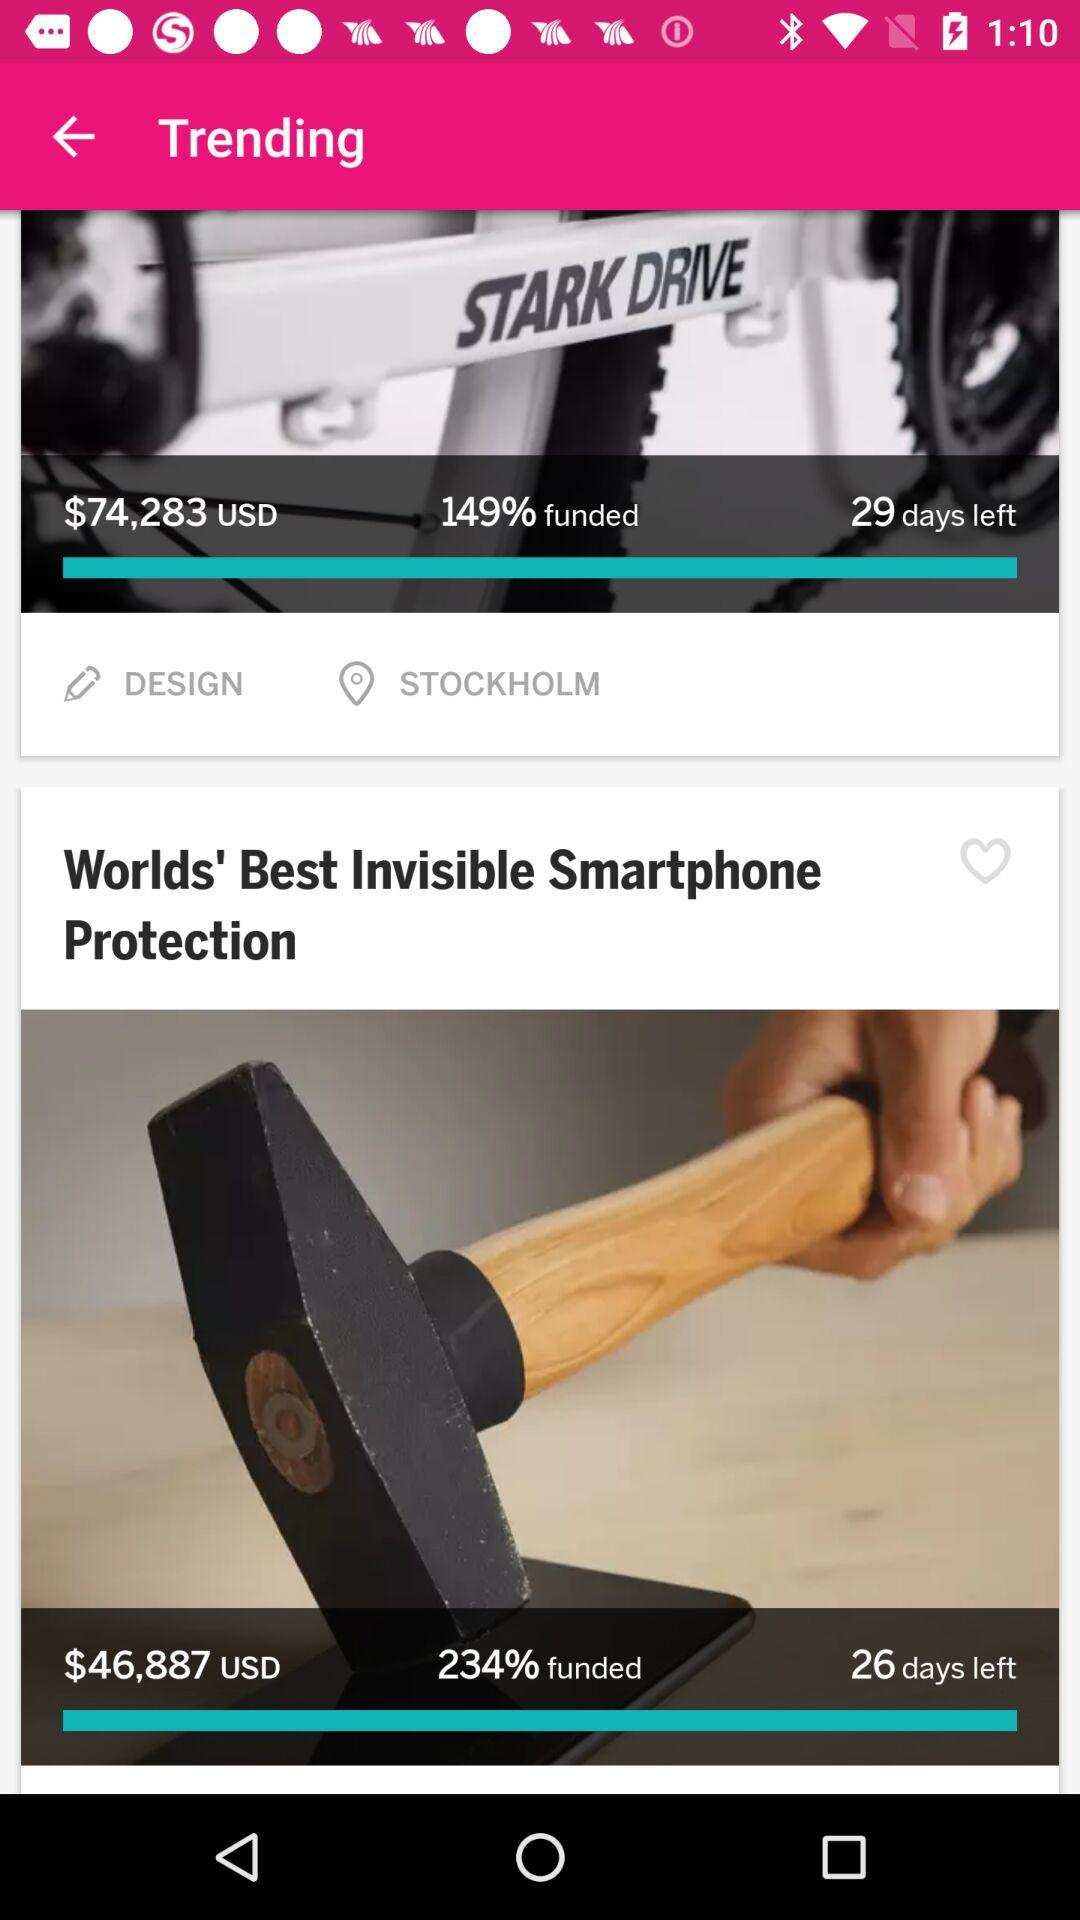How many days are left for "Worlds' Best Invisible Smartphone Protection"? "Worlds' Best Invisible Smartphone Protection" has 26 days left. 